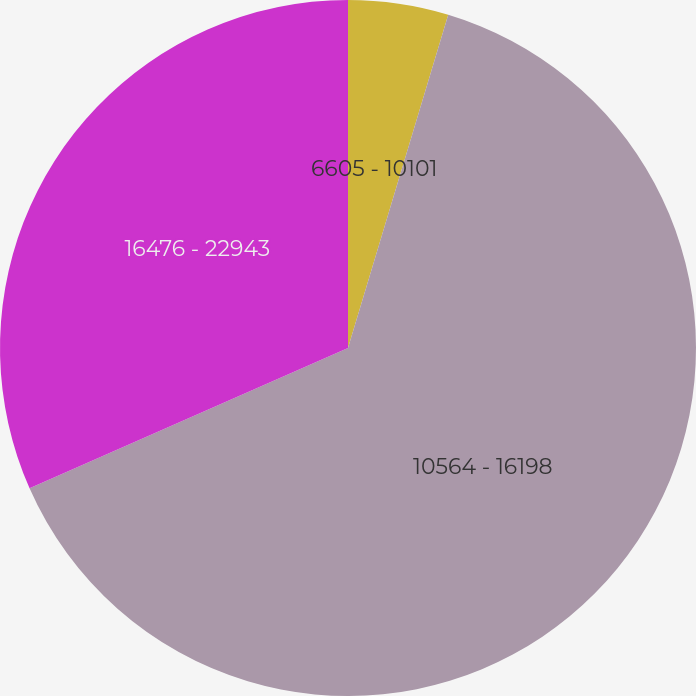<chart> <loc_0><loc_0><loc_500><loc_500><pie_chart><fcel>6605 - 10101<fcel>10564 - 16198<fcel>16476 - 22943<nl><fcel>4.65%<fcel>63.75%<fcel>31.61%<nl></chart> 